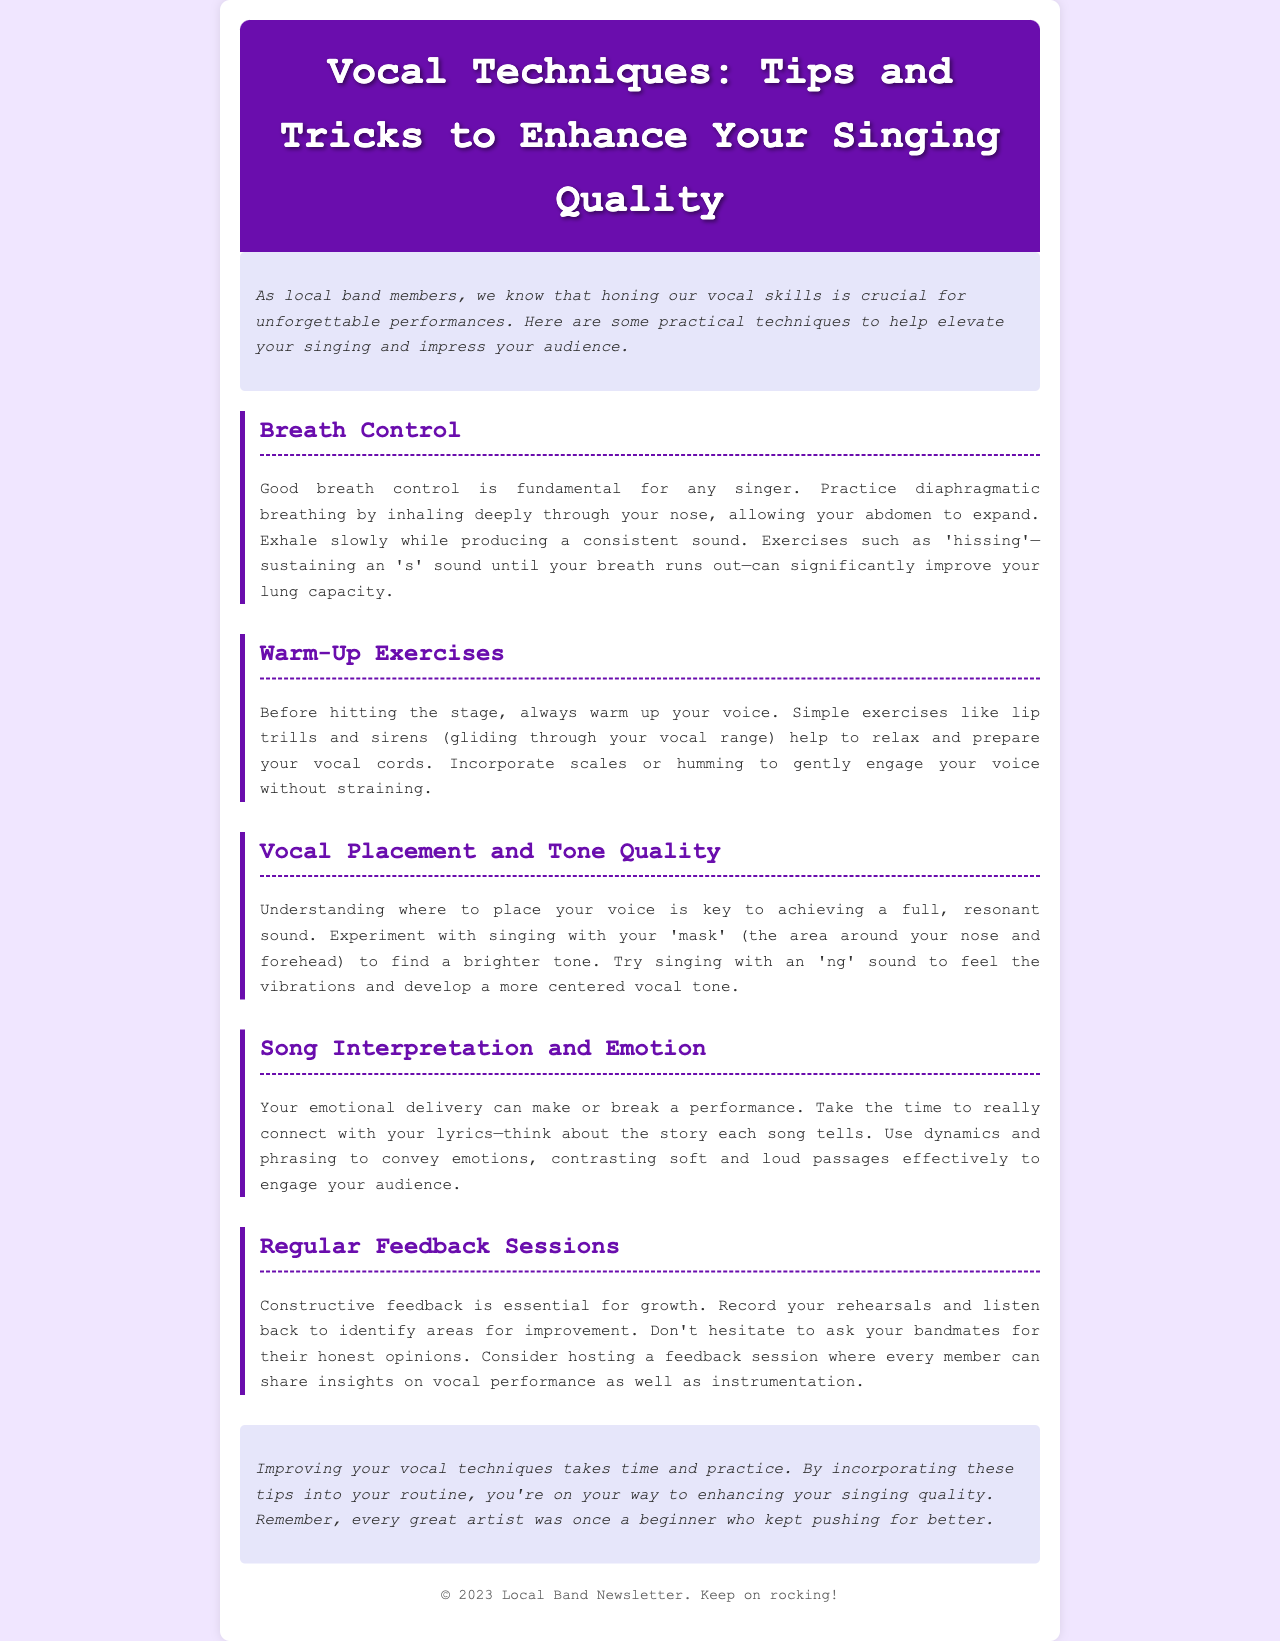What is the title of the newsletter? The title is clearly stated at the top of the document.
Answer: Vocal Techniques: Tips and Tricks to Enhance Your Singing Quality What technique involves inhaling deeply through the nose? This information relates to the section discussing fundamental singing techniques.
Answer: Diaphragmatic breathing Which exercise helps relax and prepare vocal cords? This is mentioned in the warm-up exercises section of the document.
Answer: Lip trills What sound can help achieve a brighter vocal tone? This is found in the section about vocal placement and tone quality.
Answer: 'ng' sound How many sections are there in the newsletter? A count of the distinct sections provides this information.
Answer: Five What should you do to connect with your lyrics? This relates to the advice given in the song interpretation and emotion section.
Answer: Take the time to really connect What is recommended to improve vocal performance? This is suggested in the regular feedback sessions section of the document.
Answer: Record your rehearsals What color is used for the header background? This can be determined from the visual design elements described.
Answer: Purple What is the primary focus of the newsletter? This question reflects the general purpose stated in the introduction.
Answer: Enhance singing quality 